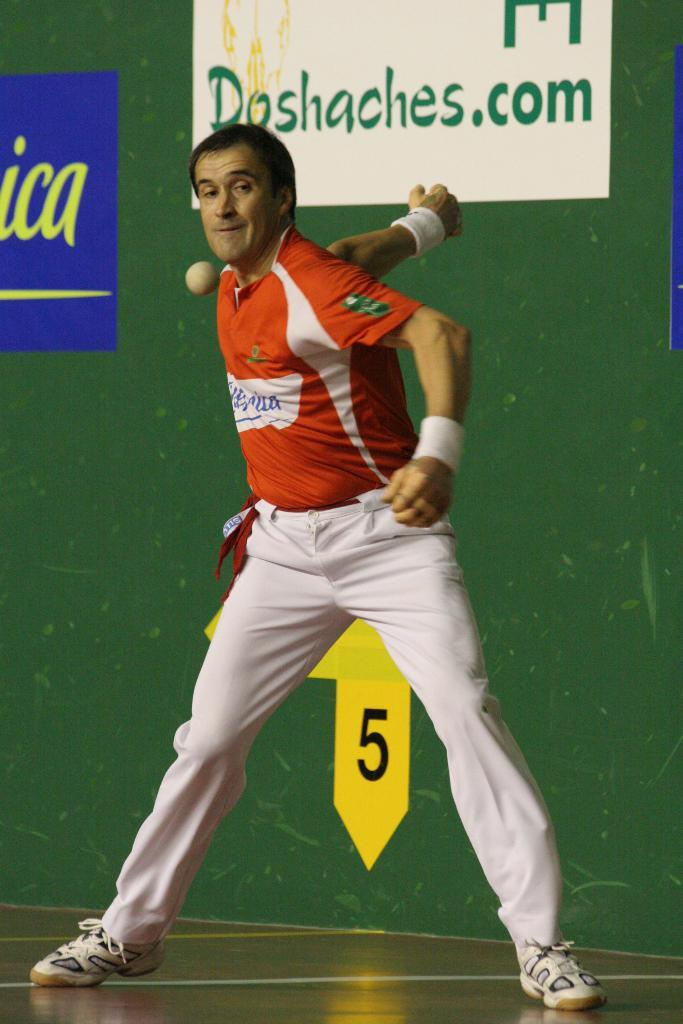Provide a one-sentence caption for the provided image. A player of a game with a sign behind him that says Doshaches.com. 